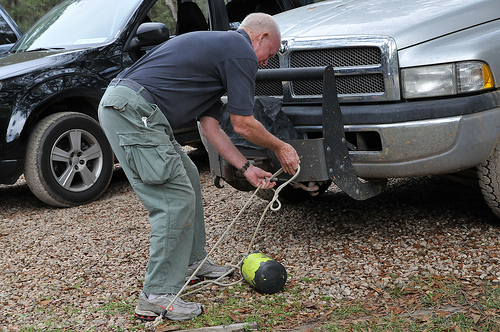What is the man holding? The man is holding a thick white rope, skillfully managing it as part of what seems to be an outdoor task involving a watermelon. 